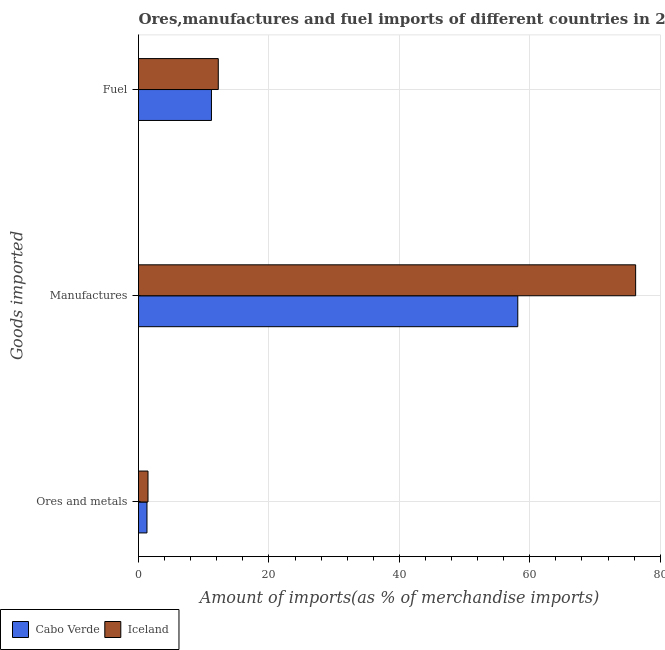How many different coloured bars are there?
Ensure brevity in your answer.  2. Are the number of bars per tick equal to the number of legend labels?
Keep it short and to the point. Yes. How many bars are there on the 2nd tick from the top?
Keep it short and to the point. 2. What is the label of the 1st group of bars from the top?
Offer a terse response. Fuel. What is the percentage of ores and metals imports in Iceland?
Your answer should be compact. 1.45. Across all countries, what is the maximum percentage of ores and metals imports?
Offer a terse response. 1.45. Across all countries, what is the minimum percentage of ores and metals imports?
Keep it short and to the point. 1.3. In which country was the percentage of fuel imports maximum?
Your answer should be very brief. Iceland. In which country was the percentage of ores and metals imports minimum?
Ensure brevity in your answer.  Cabo Verde. What is the total percentage of manufactures imports in the graph?
Provide a succinct answer. 134.39. What is the difference between the percentage of manufactures imports in Iceland and that in Cabo Verde?
Make the answer very short. 18.07. What is the difference between the percentage of manufactures imports in Iceland and the percentage of fuel imports in Cabo Verde?
Make the answer very short. 65.05. What is the average percentage of manufactures imports per country?
Make the answer very short. 67.2. What is the difference between the percentage of fuel imports and percentage of ores and metals imports in Iceland?
Offer a very short reply. 10.78. What is the ratio of the percentage of manufactures imports in Cabo Verde to that in Iceland?
Provide a short and direct response. 0.76. Is the percentage of manufactures imports in Cabo Verde less than that in Iceland?
Your answer should be very brief. Yes. Is the difference between the percentage of ores and metals imports in Iceland and Cabo Verde greater than the difference between the percentage of fuel imports in Iceland and Cabo Verde?
Provide a succinct answer. No. What is the difference between the highest and the second highest percentage of fuel imports?
Give a very brief answer. 1.05. What is the difference between the highest and the lowest percentage of fuel imports?
Provide a short and direct response. 1.05. In how many countries, is the percentage of fuel imports greater than the average percentage of fuel imports taken over all countries?
Give a very brief answer. 1. Is the sum of the percentage of manufactures imports in Cabo Verde and Iceland greater than the maximum percentage of fuel imports across all countries?
Provide a succinct answer. Yes. What does the 2nd bar from the bottom in Manufactures represents?
Offer a terse response. Iceland. How many bars are there?
Make the answer very short. 6. Are all the bars in the graph horizontal?
Keep it short and to the point. Yes. How many countries are there in the graph?
Provide a short and direct response. 2. What is the difference between two consecutive major ticks on the X-axis?
Give a very brief answer. 20. Are the values on the major ticks of X-axis written in scientific E-notation?
Provide a succinct answer. No. Does the graph contain any zero values?
Keep it short and to the point. No. How many legend labels are there?
Give a very brief answer. 2. How are the legend labels stacked?
Your answer should be compact. Horizontal. What is the title of the graph?
Keep it short and to the point. Ores,manufactures and fuel imports of different countries in 2008. Does "Bosnia and Herzegovina" appear as one of the legend labels in the graph?
Your answer should be very brief. No. What is the label or title of the X-axis?
Your response must be concise. Amount of imports(as % of merchandise imports). What is the label or title of the Y-axis?
Give a very brief answer. Goods imported. What is the Amount of imports(as % of merchandise imports) in Cabo Verde in Ores and metals?
Offer a terse response. 1.3. What is the Amount of imports(as % of merchandise imports) in Iceland in Ores and metals?
Offer a very short reply. 1.45. What is the Amount of imports(as % of merchandise imports) in Cabo Verde in Manufactures?
Keep it short and to the point. 58.16. What is the Amount of imports(as % of merchandise imports) in Iceland in Manufactures?
Ensure brevity in your answer.  76.23. What is the Amount of imports(as % of merchandise imports) in Cabo Verde in Fuel?
Provide a short and direct response. 11.19. What is the Amount of imports(as % of merchandise imports) of Iceland in Fuel?
Make the answer very short. 12.23. Across all Goods imported, what is the maximum Amount of imports(as % of merchandise imports) of Cabo Verde?
Ensure brevity in your answer.  58.16. Across all Goods imported, what is the maximum Amount of imports(as % of merchandise imports) in Iceland?
Provide a short and direct response. 76.23. Across all Goods imported, what is the minimum Amount of imports(as % of merchandise imports) of Cabo Verde?
Your response must be concise. 1.3. Across all Goods imported, what is the minimum Amount of imports(as % of merchandise imports) of Iceland?
Ensure brevity in your answer.  1.45. What is the total Amount of imports(as % of merchandise imports) in Cabo Verde in the graph?
Provide a short and direct response. 70.64. What is the total Amount of imports(as % of merchandise imports) in Iceland in the graph?
Give a very brief answer. 89.92. What is the difference between the Amount of imports(as % of merchandise imports) in Cabo Verde in Ores and metals and that in Manufactures?
Offer a terse response. -56.86. What is the difference between the Amount of imports(as % of merchandise imports) of Iceland in Ores and metals and that in Manufactures?
Offer a very short reply. -74.78. What is the difference between the Amount of imports(as % of merchandise imports) in Cabo Verde in Ores and metals and that in Fuel?
Your answer should be compact. -9.89. What is the difference between the Amount of imports(as % of merchandise imports) of Iceland in Ores and metals and that in Fuel?
Provide a succinct answer. -10.78. What is the difference between the Amount of imports(as % of merchandise imports) in Cabo Verde in Manufactures and that in Fuel?
Provide a succinct answer. 46.97. What is the difference between the Amount of imports(as % of merchandise imports) of Iceland in Manufactures and that in Fuel?
Your answer should be very brief. 64. What is the difference between the Amount of imports(as % of merchandise imports) of Cabo Verde in Ores and metals and the Amount of imports(as % of merchandise imports) of Iceland in Manufactures?
Give a very brief answer. -74.93. What is the difference between the Amount of imports(as % of merchandise imports) in Cabo Verde in Ores and metals and the Amount of imports(as % of merchandise imports) in Iceland in Fuel?
Offer a terse response. -10.93. What is the difference between the Amount of imports(as % of merchandise imports) in Cabo Verde in Manufactures and the Amount of imports(as % of merchandise imports) in Iceland in Fuel?
Keep it short and to the point. 45.93. What is the average Amount of imports(as % of merchandise imports) of Cabo Verde per Goods imported?
Ensure brevity in your answer.  23.55. What is the average Amount of imports(as % of merchandise imports) in Iceland per Goods imported?
Provide a short and direct response. 29.97. What is the difference between the Amount of imports(as % of merchandise imports) in Cabo Verde and Amount of imports(as % of merchandise imports) in Iceland in Ores and metals?
Provide a succinct answer. -0.16. What is the difference between the Amount of imports(as % of merchandise imports) of Cabo Verde and Amount of imports(as % of merchandise imports) of Iceland in Manufactures?
Keep it short and to the point. -18.07. What is the difference between the Amount of imports(as % of merchandise imports) of Cabo Verde and Amount of imports(as % of merchandise imports) of Iceland in Fuel?
Ensure brevity in your answer.  -1.05. What is the ratio of the Amount of imports(as % of merchandise imports) of Cabo Verde in Ores and metals to that in Manufactures?
Provide a short and direct response. 0.02. What is the ratio of the Amount of imports(as % of merchandise imports) of Iceland in Ores and metals to that in Manufactures?
Ensure brevity in your answer.  0.02. What is the ratio of the Amount of imports(as % of merchandise imports) in Cabo Verde in Ores and metals to that in Fuel?
Give a very brief answer. 0.12. What is the ratio of the Amount of imports(as % of merchandise imports) of Iceland in Ores and metals to that in Fuel?
Give a very brief answer. 0.12. What is the ratio of the Amount of imports(as % of merchandise imports) in Cabo Verde in Manufactures to that in Fuel?
Your response must be concise. 5.2. What is the ratio of the Amount of imports(as % of merchandise imports) in Iceland in Manufactures to that in Fuel?
Offer a terse response. 6.23. What is the difference between the highest and the second highest Amount of imports(as % of merchandise imports) of Cabo Verde?
Your answer should be compact. 46.97. What is the difference between the highest and the second highest Amount of imports(as % of merchandise imports) in Iceland?
Give a very brief answer. 64. What is the difference between the highest and the lowest Amount of imports(as % of merchandise imports) in Cabo Verde?
Offer a terse response. 56.86. What is the difference between the highest and the lowest Amount of imports(as % of merchandise imports) in Iceland?
Keep it short and to the point. 74.78. 